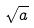Convert formula to latex. <formula><loc_0><loc_0><loc_500><loc_500>\sqrt { a }</formula> 